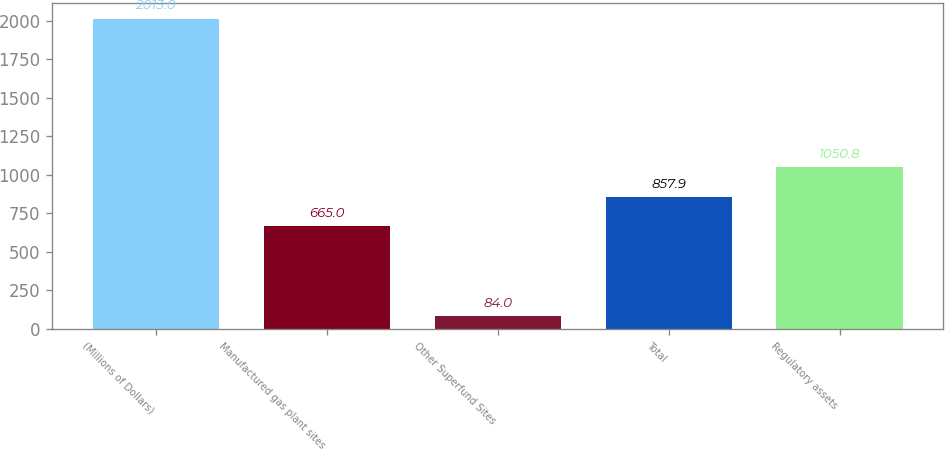Convert chart. <chart><loc_0><loc_0><loc_500><loc_500><bar_chart><fcel>(Millions of Dollars)<fcel>Manufactured gas plant sites<fcel>Other Superfund Sites<fcel>Total<fcel>Regulatory assets<nl><fcel>2013<fcel>665<fcel>84<fcel>857.9<fcel>1050.8<nl></chart> 